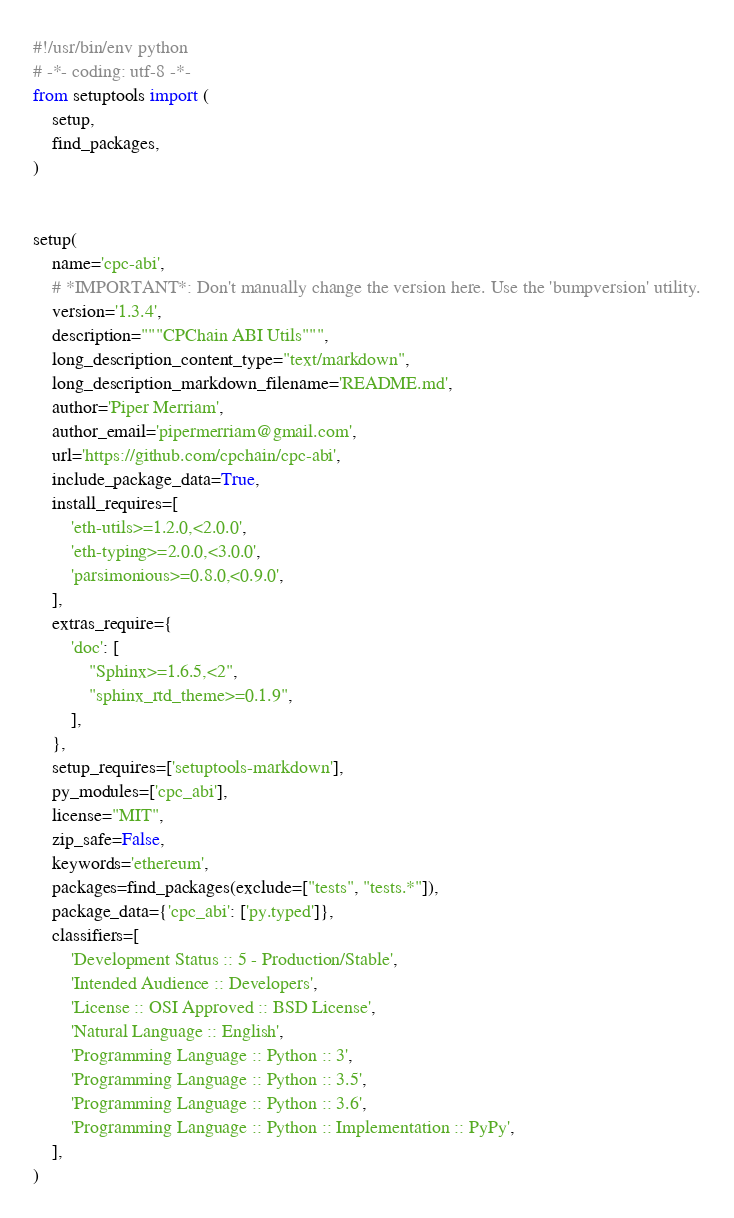<code> <loc_0><loc_0><loc_500><loc_500><_Python_>#!/usr/bin/env python
# -*- coding: utf-8 -*-
from setuptools import (
    setup,
    find_packages,
)


setup(
    name='cpc-abi',
    # *IMPORTANT*: Don't manually change the version here. Use the 'bumpversion' utility.
    version='1.3.4',
    description="""CPChain ABI Utils""",
    long_description_content_type="text/markdown",
    long_description_markdown_filename='README.md',
    author='Piper Merriam',
    author_email='pipermerriam@gmail.com',
    url='https://github.com/cpchain/cpc-abi',
    include_package_data=True,
    install_requires=[
        'eth-utils>=1.2.0,<2.0.0',
        'eth-typing>=2.0.0,<3.0.0',
        'parsimonious>=0.8.0,<0.9.0',
    ],
    extras_require={
        'doc': [
            "Sphinx>=1.6.5,<2",
            "sphinx_rtd_theme>=0.1.9",
        ],
    },
    setup_requires=['setuptools-markdown'],
    py_modules=['cpc_abi'],
    license="MIT",
    zip_safe=False,
    keywords='ethereum',
    packages=find_packages(exclude=["tests", "tests.*"]),
    package_data={'cpc_abi': ['py.typed']},
    classifiers=[
        'Development Status :: 5 - Production/Stable',
        'Intended Audience :: Developers',
        'License :: OSI Approved :: BSD License',
        'Natural Language :: English',
        'Programming Language :: Python :: 3',
        'Programming Language :: Python :: 3.5',
        'Programming Language :: Python :: 3.6',
        'Programming Language :: Python :: Implementation :: PyPy',
    ],
)
</code> 